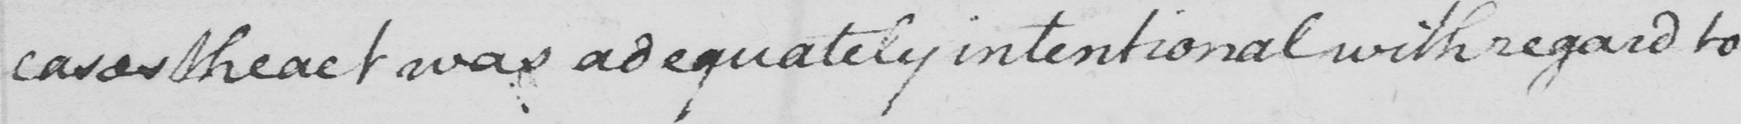What text is written in this handwritten line? cases the act was adequately intentional with regard to 